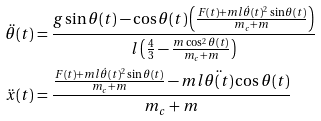Convert formula to latex. <formula><loc_0><loc_0><loc_500><loc_500>\ddot { \theta } ( t ) & = \frac { g \sin \theta ( t ) - \cos \theta ( t ) \left ( \frac { F ( t ) + m l \dot { \theta } ( t ) ^ { 2 } \sin \theta ( t ) } { m _ { c } + m } \right ) } { l \left ( \frac { 4 } { 3 } - \frac { m \cos ^ { 2 } \theta ( t ) } { m _ { c } + m } \right ) } \\ \ddot { x } ( t ) & = \frac { \frac { F ( t ) + m l \dot { \theta } ( t ) ^ { 2 } \sin \theta ( t ) } { m _ { c } + m } - m l \ddot { \theta ( t ) } \cos { \theta ( t ) } } { m _ { c } + m }</formula> 